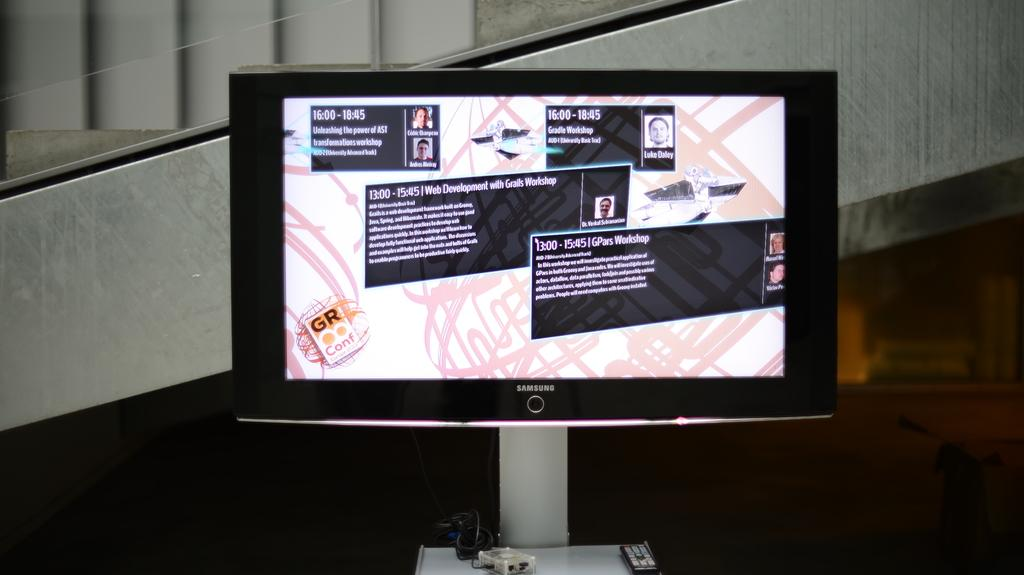<image>
Share a concise interpretation of the image provided. The screen shows that the GPars Workshop starts at 13.00. 